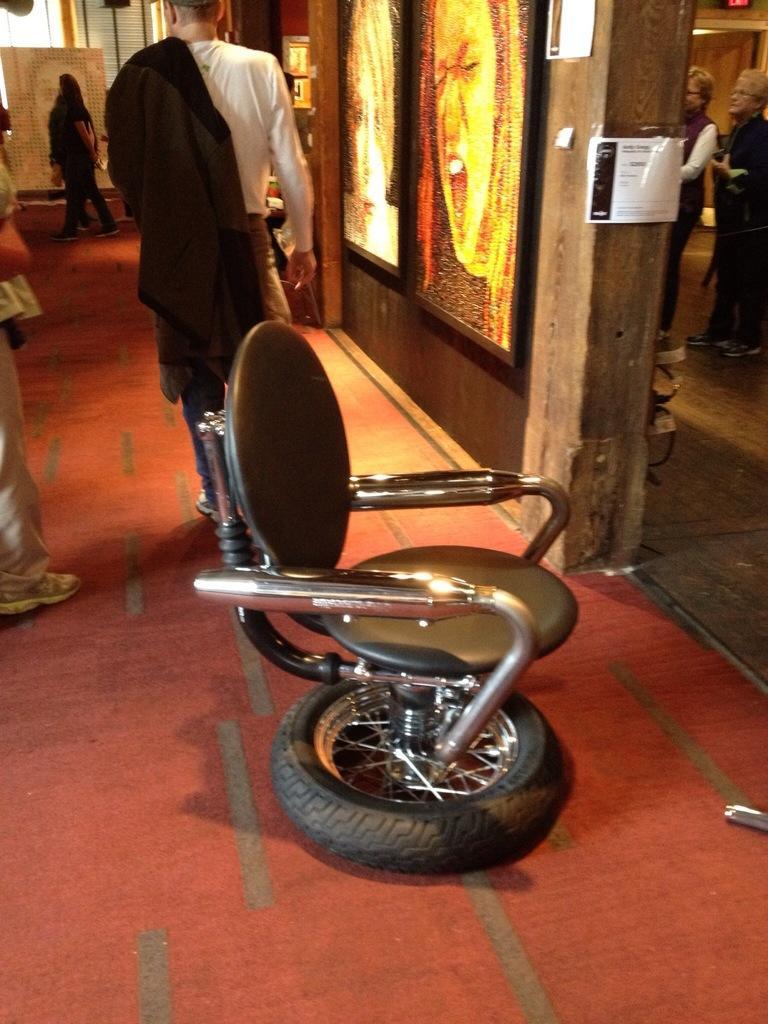Please provide a concise description of this image. there is a chair. behind that there are people walking. at the right there are photo frames. 